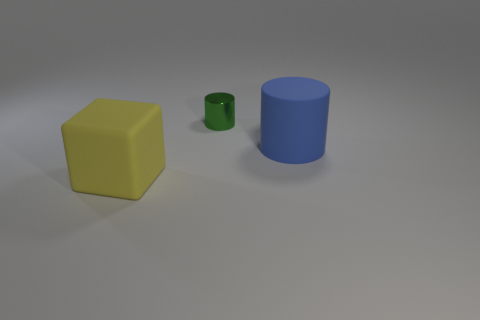Add 1 blue rubber cylinders. How many objects exist? 4 Subtract all cylinders. How many objects are left? 1 Subtract 0 purple cylinders. How many objects are left? 3 Subtract all large blue rubber cylinders. Subtract all big yellow objects. How many objects are left? 1 Add 3 small metallic things. How many small metallic things are left? 4 Add 1 tiny purple matte cylinders. How many tiny purple matte cylinders exist? 1 